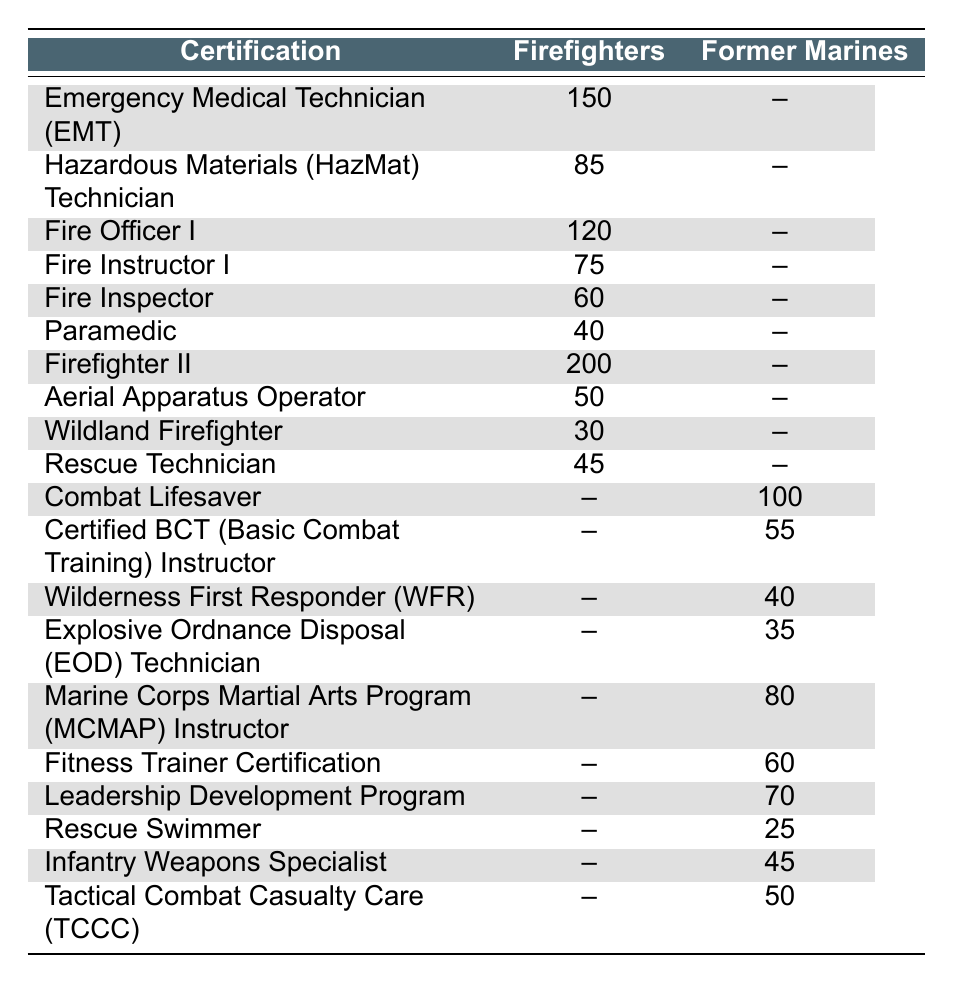What certification has the highest number of holders among firefighters? The certification with the highest number of holders among firefighters is "Firefighter II," with 200 certifications.
Answer: Firefighter II How many more Emergency Medical Technician (EMT) certifications do firefighters have compared to the Marine Corps Martial Arts Program (MCMAP) Instructor certifications? Firefighters have 150 EMT certifications and there are 80 MCMAP Instructor certifications held by Marines. The difference is 150 - 80 = 70.
Answer: 70 True or False: More firefighters are certified as Paramedics than former Marines as Tactical Combat Casualty Care (TCCC) holders. Firefighters have 40 Paramedic certifications, while former Marines have 50 TCCC certifications. Since 40 is less than 50, the statement is false.
Answer: False What is the total number of hazardous materials certifications held by firefighters and combat lifesaver certifications held by former Marines combined? Firefighters have 85 Hazardous Materials certifications, and former Marines have 100 Combat Lifesaver certifications. Combining these, we get 85 + 100 = 185.
Answer: 185 Which has a higher count, the total number of firefighter certifications or the total number of former Marine certifications? First, we find the total for firefighters: 150 + 85 + 120 + 75 + 60 + 40 + 200 + 50 + 30 + 45 = 855. Next, for former Marines: 100 + 55 + 40 + 35 + 80 + 60 + 70 + 25 + 45 + 50 = 510. Since 855 > 510, firefighters have a higher count of certifications.
Answer: Firefighters How many certifications do former Marines have that are more than 50? The certifications held by former Marines that are more than 50 are: Combat Lifesaver (100), MCMAP Instructor (80), Fitness Trainer Certification (60), and Leadership Development Program (70), summing up to 4 certifications.
Answer: 4 What is the average number of certifications held by firefighters? To find the average, we sum the total firefighter certifications: 150 + 85 + 120 + 75 + 60 + 40 + 200 + 50 + 30 + 45 = 855. Since there are 10 different certifications, we divide 855 by 10, which results in an average of 85.5.
Answer: 85.5 Are there any certifications held by firefighters that are not held by former Marines? Firefighter certifications include EMT, Hazardous Materials, Fire Officer I, Fire Instructor I, Fire Inspector, Paramedic, Firefighter II, Aerial Apparatus Operator, Wildland Firefighter, and Rescue Technician. None of these certifications appears in the former Marines' certifications, confirming that there are certifications unique to firefighters.
Answer: Yes 